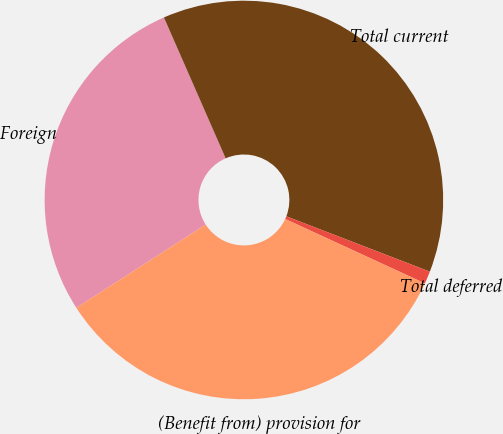Convert chart. <chart><loc_0><loc_0><loc_500><loc_500><pie_chart><fcel>Foreign<fcel>Total current<fcel>Total deferred<fcel>(Benefit from) provision for<nl><fcel>27.53%<fcel>37.43%<fcel>1.02%<fcel>34.02%<nl></chart> 